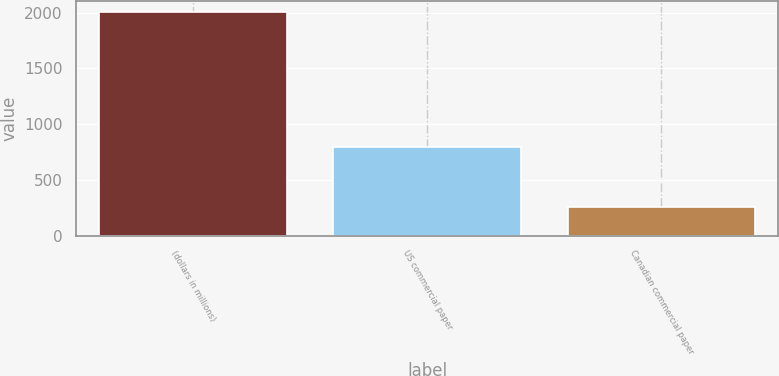Convert chart. <chart><loc_0><loc_0><loc_500><loc_500><bar_chart><fcel>(dollars in millions)<fcel>US commercial paper<fcel>Canadian commercial paper<nl><fcel>2005<fcel>797.3<fcel>260.4<nl></chart> 